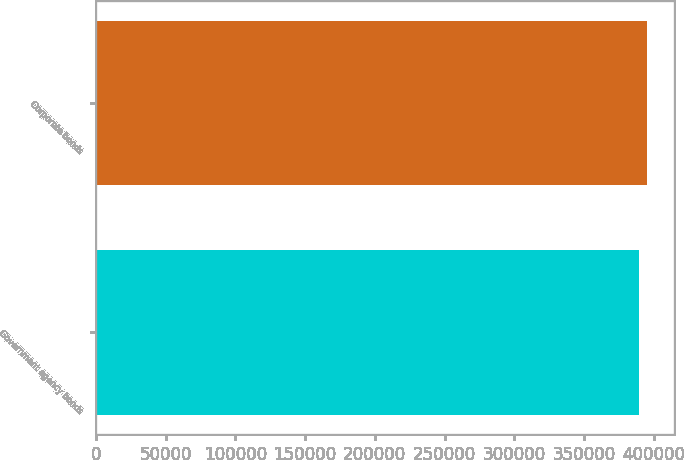Convert chart. <chart><loc_0><loc_0><loc_500><loc_500><bar_chart><fcel>Government agency bonds<fcel>Corporate bonds<nl><fcel>389394<fcel>394856<nl></chart> 